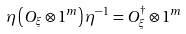Convert formula to latex. <formula><loc_0><loc_0><loc_500><loc_500>\eta \left ( O _ { \xi } \otimes 1 ^ { m } \right ) \eta ^ { - 1 } = O _ { \xi } ^ { \dagger } \otimes 1 ^ { m }</formula> 